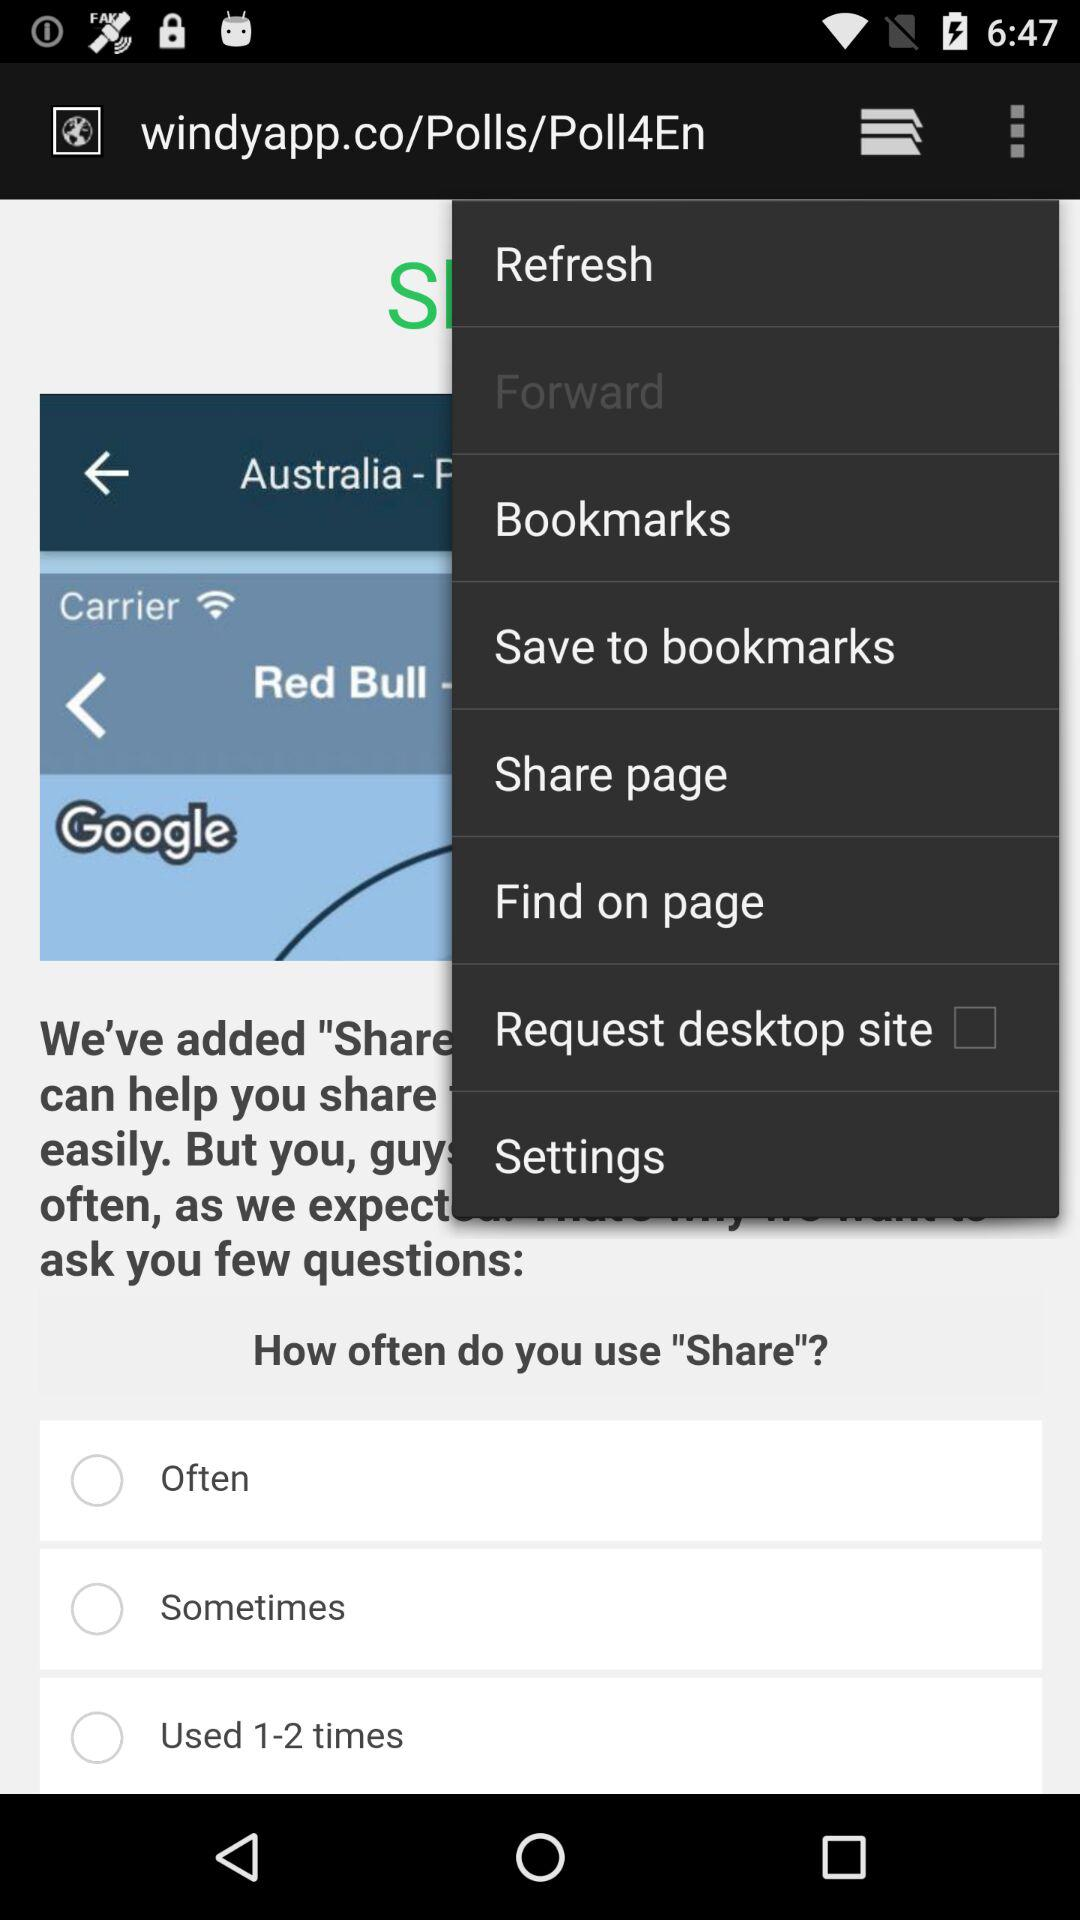What is the status of the "Request desktop site" setting? The status is off. 